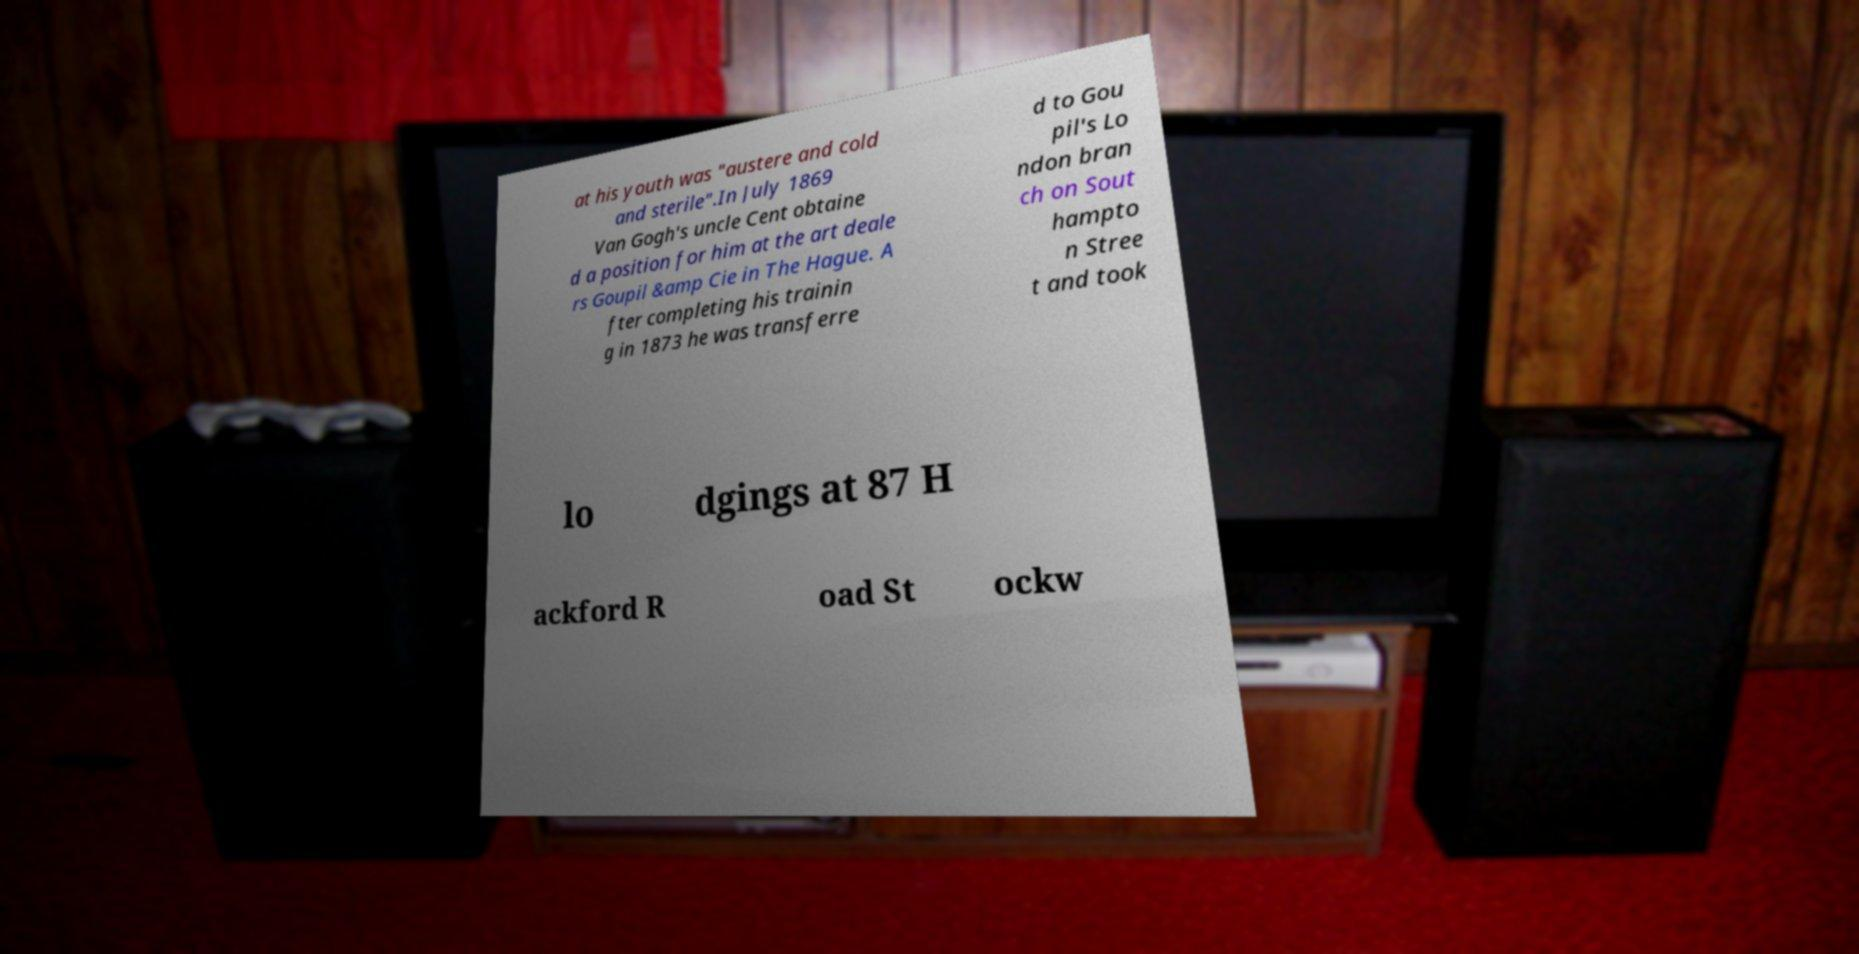Can you read and provide the text displayed in the image?This photo seems to have some interesting text. Can you extract and type it out for me? at his youth was "austere and cold and sterile".In July 1869 Van Gogh's uncle Cent obtaine d a position for him at the art deale rs Goupil &amp Cie in The Hague. A fter completing his trainin g in 1873 he was transferre d to Gou pil's Lo ndon bran ch on Sout hampto n Stree t and took lo dgings at 87 H ackford R oad St ockw 